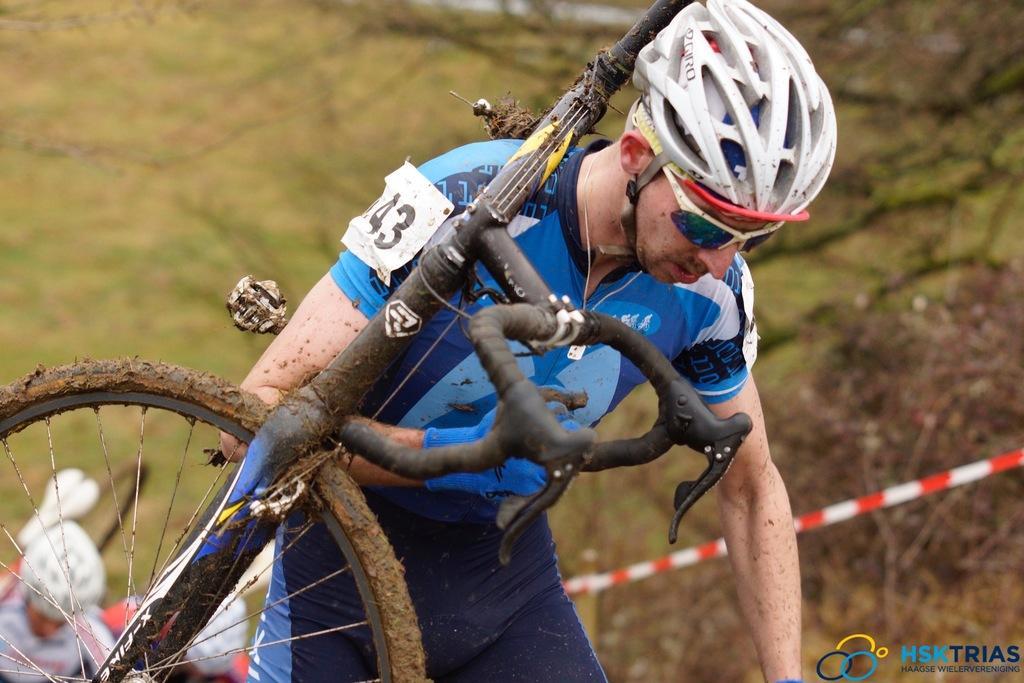Can you describe this image briefly? In this picture there is a man who is wearing helmet, gloves, t-shirt and trouser. He is holding a bicycle. In the bottom left corner I can see two people were riding a bicycle. In the background I can see the trees, plants and grass. In the bottom right corner I can see the watermark. 